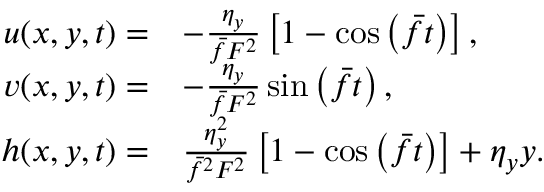<formula> <loc_0><loc_0><loc_500><loc_500>\begin{array} { r l } { u ( x , y , t ) = } & { - \frac { \eta _ { y } } { \bar { f } F ^ { 2 } } \left [ 1 - \cos \left ( \bar { f } t \right ) \right ] , } \\ { v ( x , y , t ) = } & { - \frac { \eta _ { y } } { \bar { f } F ^ { 2 } } \sin \left ( \bar { f } t \right ) , } \\ { h ( x , y , t ) = } & { \frac { \eta _ { y } ^ { 2 } } { \bar { f } ^ { 2 } F ^ { 2 } } \left [ 1 - \cos \left ( \bar { f } t \right ) \right ] + \eta _ { y } y . } \end{array}</formula> 